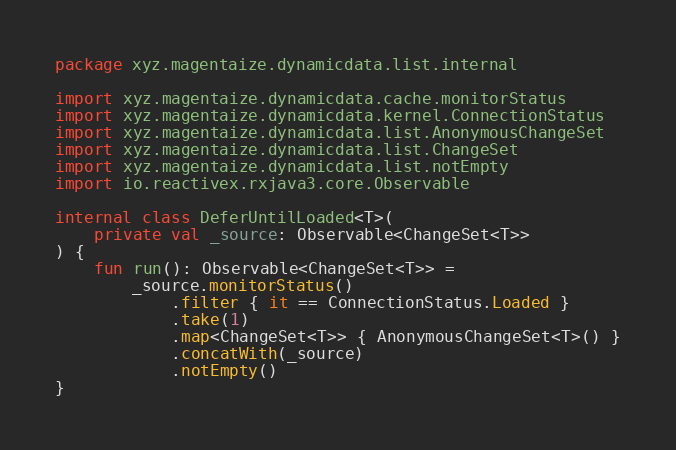<code> <loc_0><loc_0><loc_500><loc_500><_Kotlin_>package xyz.magentaize.dynamicdata.list.internal

import xyz.magentaize.dynamicdata.cache.monitorStatus
import xyz.magentaize.dynamicdata.kernel.ConnectionStatus
import xyz.magentaize.dynamicdata.list.AnonymousChangeSet
import xyz.magentaize.dynamicdata.list.ChangeSet
import xyz.magentaize.dynamicdata.list.notEmpty
import io.reactivex.rxjava3.core.Observable

internal class DeferUntilLoaded<T>(
    private val _source: Observable<ChangeSet<T>>
) {
    fun run(): Observable<ChangeSet<T>> =
        _source.monitorStatus()
            .filter { it == ConnectionStatus.Loaded }
            .take(1)
            .map<ChangeSet<T>> { AnonymousChangeSet<T>() }
            .concatWith(_source)
            .notEmpty()
}
</code> 